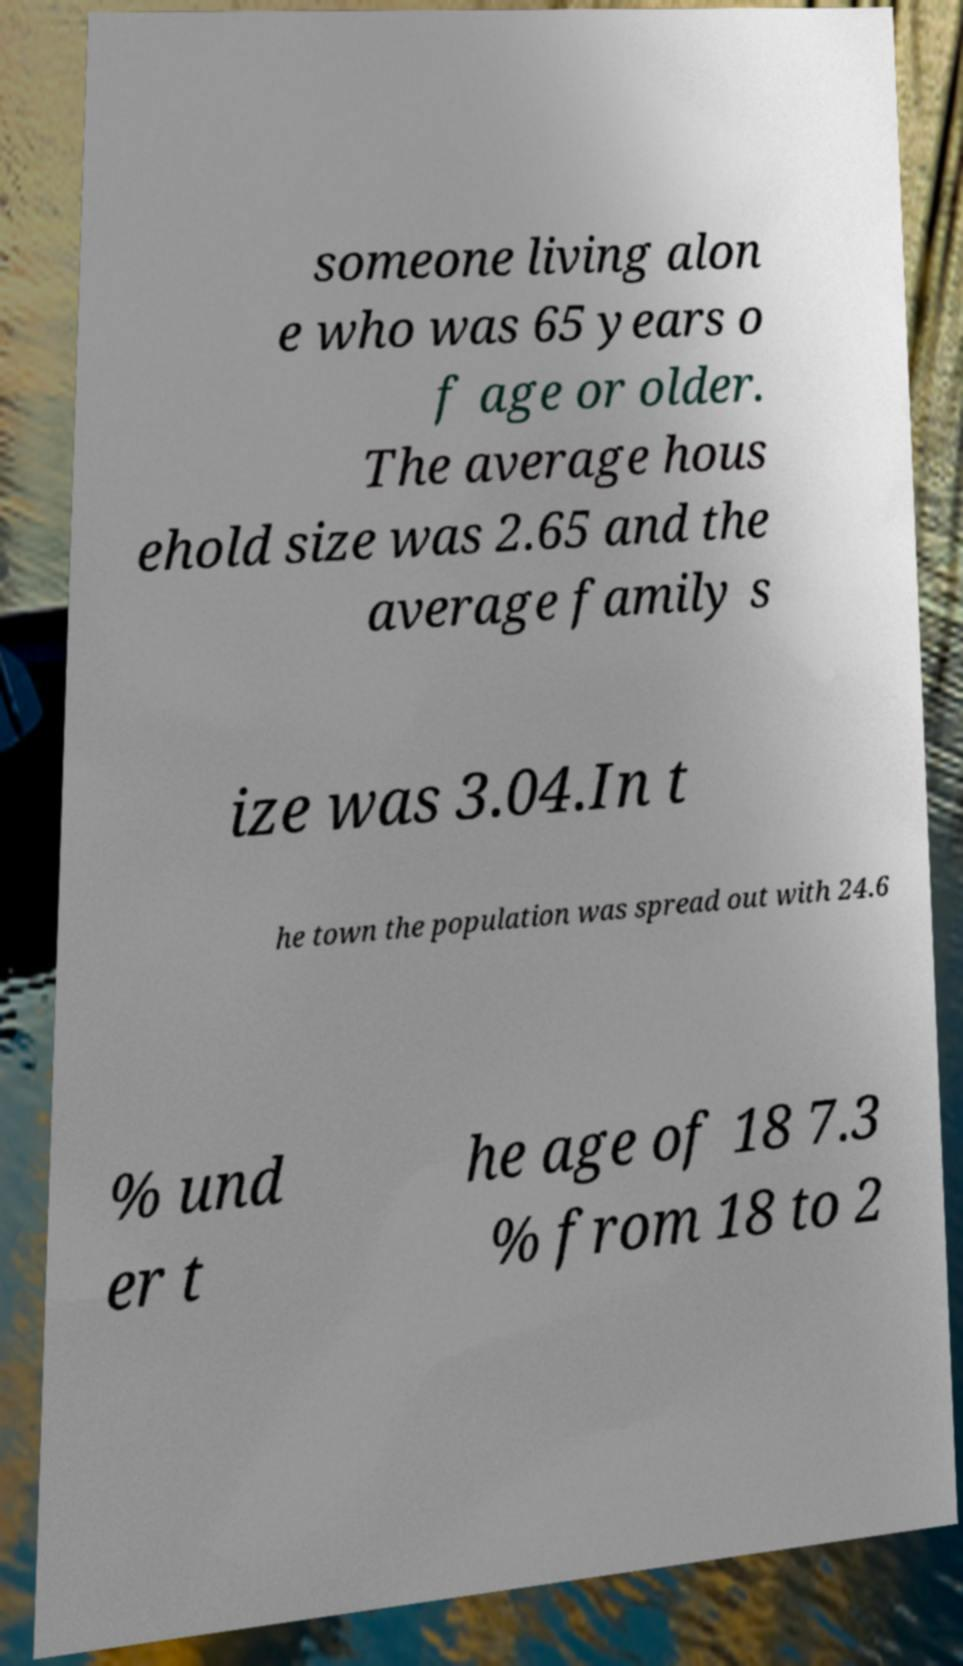Can you accurately transcribe the text from the provided image for me? someone living alon e who was 65 years o f age or older. The average hous ehold size was 2.65 and the average family s ize was 3.04.In t he town the population was spread out with 24.6 % und er t he age of 18 7.3 % from 18 to 2 